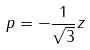<formula> <loc_0><loc_0><loc_500><loc_500>p = - \frac { 1 } { \sqrt { 3 } } z</formula> 